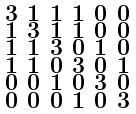Convert formula to latex. <formula><loc_0><loc_0><loc_500><loc_500>\begin{smallmatrix} 3 & 1 & 1 & 1 & 0 & 0 \\ 1 & 3 & 1 & 1 & 0 & 0 \\ 1 & 1 & 3 & 0 & 1 & 0 \\ 1 & 1 & 0 & 3 & 0 & 1 \\ 0 & 0 & 1 & 0 & 3 & 0 \\ 0 & 0 & 0 & 1 & 0 & 3 \end{smallmatrix}</formula> 